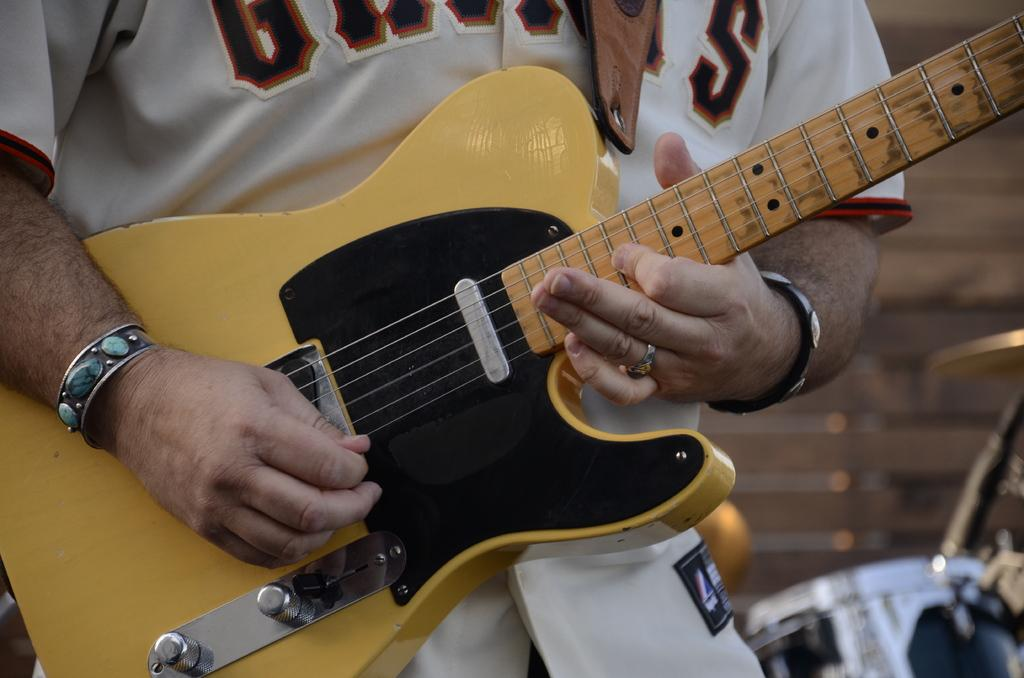What is the main subject of the image? There is a person in the image. What is the person doing in the image? The person is playing a guitar. Can you describe the background of the image? The background of the image is blurred. What type of paint is being used to create the current in the image? There is no current or paint present in the image; it features a person playing a guitar with a blurred background. 